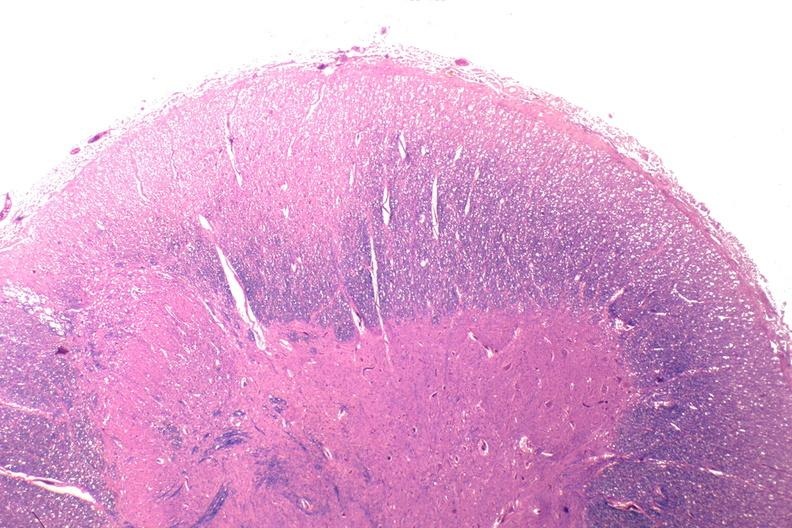s metastatic carcinoma colon present?
Answer the question using a single word or phrase. No 